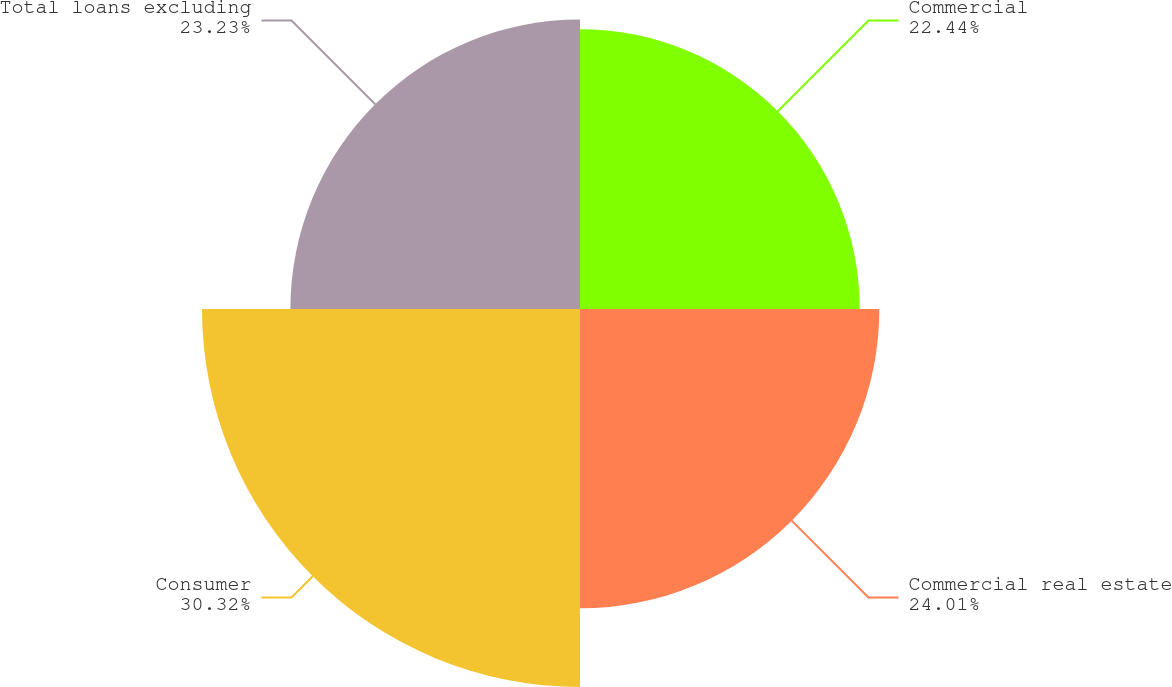<chart> <loc_0><loc_0><loc_500><loc_500><pie_chart><fcel>Commercial<fcel>Commercial real estate<fcel>Consumer<fcel>Total loans excluding<nl><fcel>22.44%<fcel>24.01%<fcel>30.32%<fcel>23.23%<nl></chart> 